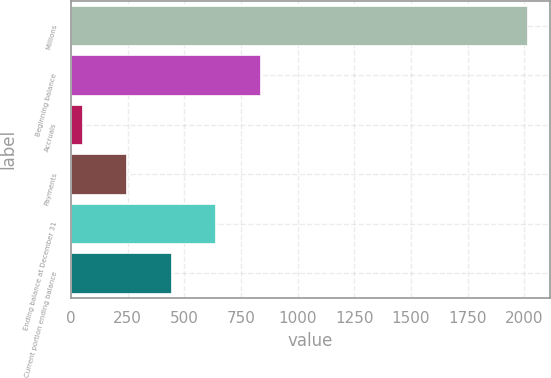Convert chart to OTSL. <chart><loc_0><loc_0><loc_500><loc_500><bar_chart><fcel>Millions<fcel>Beginning balance<fcel>Accruals<fcel>Payments<fcel>Ending balance at December 31<fcel>Current portion ending balance<nl><fcel>2012<fcel>833.6<fcel>48<fcel>244.4<fcel>637.2<fcel>440.8<nl></chart> 